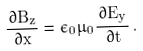<formula> <loc_0><loc_0><loc_500><loc_500>\frac { \, \partial B _ { z } } { \, \partial x } = \epsilon _ { 0 } \mu _ { 0 } \frac { \, \partial E _ { y } } { \, \partial t } \, .</formula> 